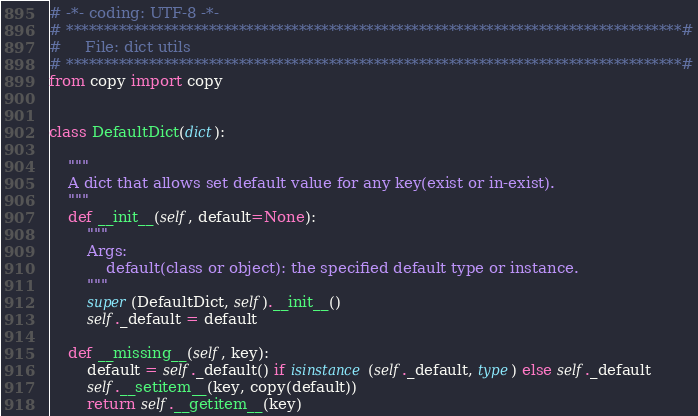Convert code to text. <code><loc_0><loc_0><loc_500><loc_500><_Python_># -*- coding: UTF-8 -*-
# **********************************************************************************#
#     File: dict utils
# **********************************************************************************#
from copy import copy


class DefaultDict(dict):

    """
    A dict that allows set default value for any key(exist or in-exist).
    """
    def __init__(self, default=None):
        """
        Args:
            default(class or object): the specified default type or instance.
        """
        super(DefaultDict, self).__init__()
        self._default = default

    def __missing__(self, key):
        default = self._default() if isinstance(self._default, type) else self._default
        self.__setitem__(key, copy(default))
        return self.__getitem__(key)
</code> 